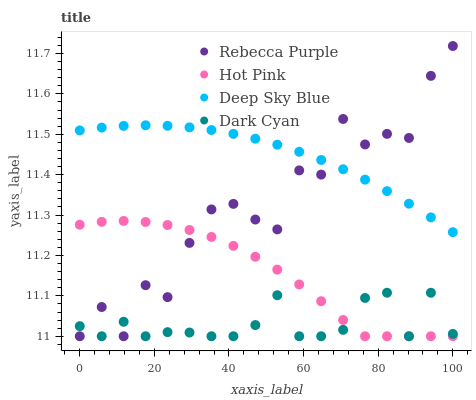Does Dark Cyan have the minimum area under the curve?
Answer yes or no. Yes. Does Deep Sky Blue have the maximum area under the curve?
Answer yes or no. Yes. Does Hot Pink have the minimum area under the curve?
Answer yes or no. No. Does Hot Pink have the maximum area under the curve?
Answer yes or no. No. Is Deep Sky Blue the smoothest?
Answer yes or no. Yes. Is Rebecca Purple the roughest?
Answer yes or no. Yes. Is Hot Pink the smoothest?
Answer yes or no. No. Is Hot Pink the roughest?
Answer yes or no. No. Does Dark Cyan have the lowest value?
Answer yes or no. Yes. Does Deep Sky Blue have the lowest value?
Answer yes or no. No. Does Rebecca Purple have the highest value?
Answer yes or no. Yes. Does Hot Pink have the highest value?
Answer yes or no. No. Is Hot Pink less than Deep Sky Blue?
Answer yes or no. Yes. Is Deep Sky Blue greater than Dark Cyan?
Answer yes or no. Yes. Does Dark Cyan intersect Rebecca Purple?
Answer yes or no. Yes. Is Dark Cyan less than Rebecca Purple?
Answer yes or no. No. Is Dark Cyan greater than Rebecca Purple?
Answer yes or no. No. Does Hot Pink intersect Deep Sky Blue?
Answer yes or no. No. 